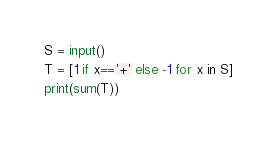Convert code to text. <code><loc_0><loc_0><loc_500><loc_500><_Python_>S = input()
T = [1 if x=='+' else -1 for x in S]
print(sum(T))</code> 